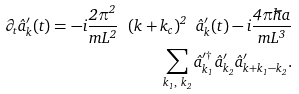<formula> <loc_0><loc_0><loc_500><loc_500>\partial _ { t } \hat { a } ^ { \prime } _ { k } ( t ) = - i \frac { 2 \pi ^ { 2 } } { m L ^ { 2 } } \ ( k + k _ { c } ) ^ { 2 } \ \hat { a } ^ { \prime } _ { k } ( t ) - i \frac { 4 \pi \hbar { a } } { m L ^ { 3 } } \\ \sum _ { k _ { 1 } , \ k _ { 2 } } \hat { a } ^ { \prime \dagger } _ { k _ { 1 } } \hat { a } ^ { \prime } _ { k _ { 2 } } \hat { a } ^ { \prime } _ { k + k _ { 1 } - k _ { 2 } } .</formula> 